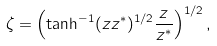Convert formula to latex. <formula><loc_0><loc_0><loc_500><loc_500>\zeta = \left ( \tanh ^ { - 1 } ( z z ^ { * } ) ^ { 1 / 2 } \frac { z } { z ^ { * } } \right ) ^ { 1 / 2 } ,</formula> 